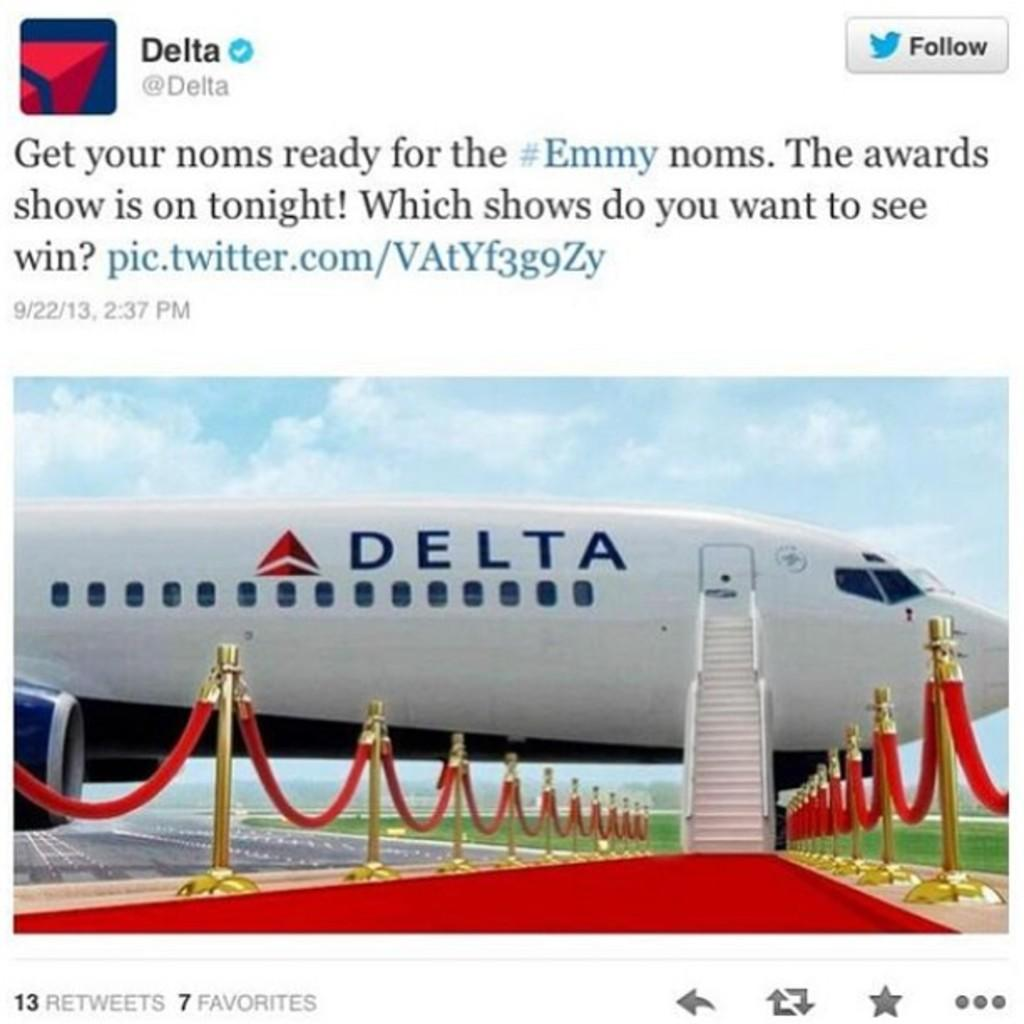<image>
Offer a succinct explanation of the picture presented. a plane that is from Delta on the ground 